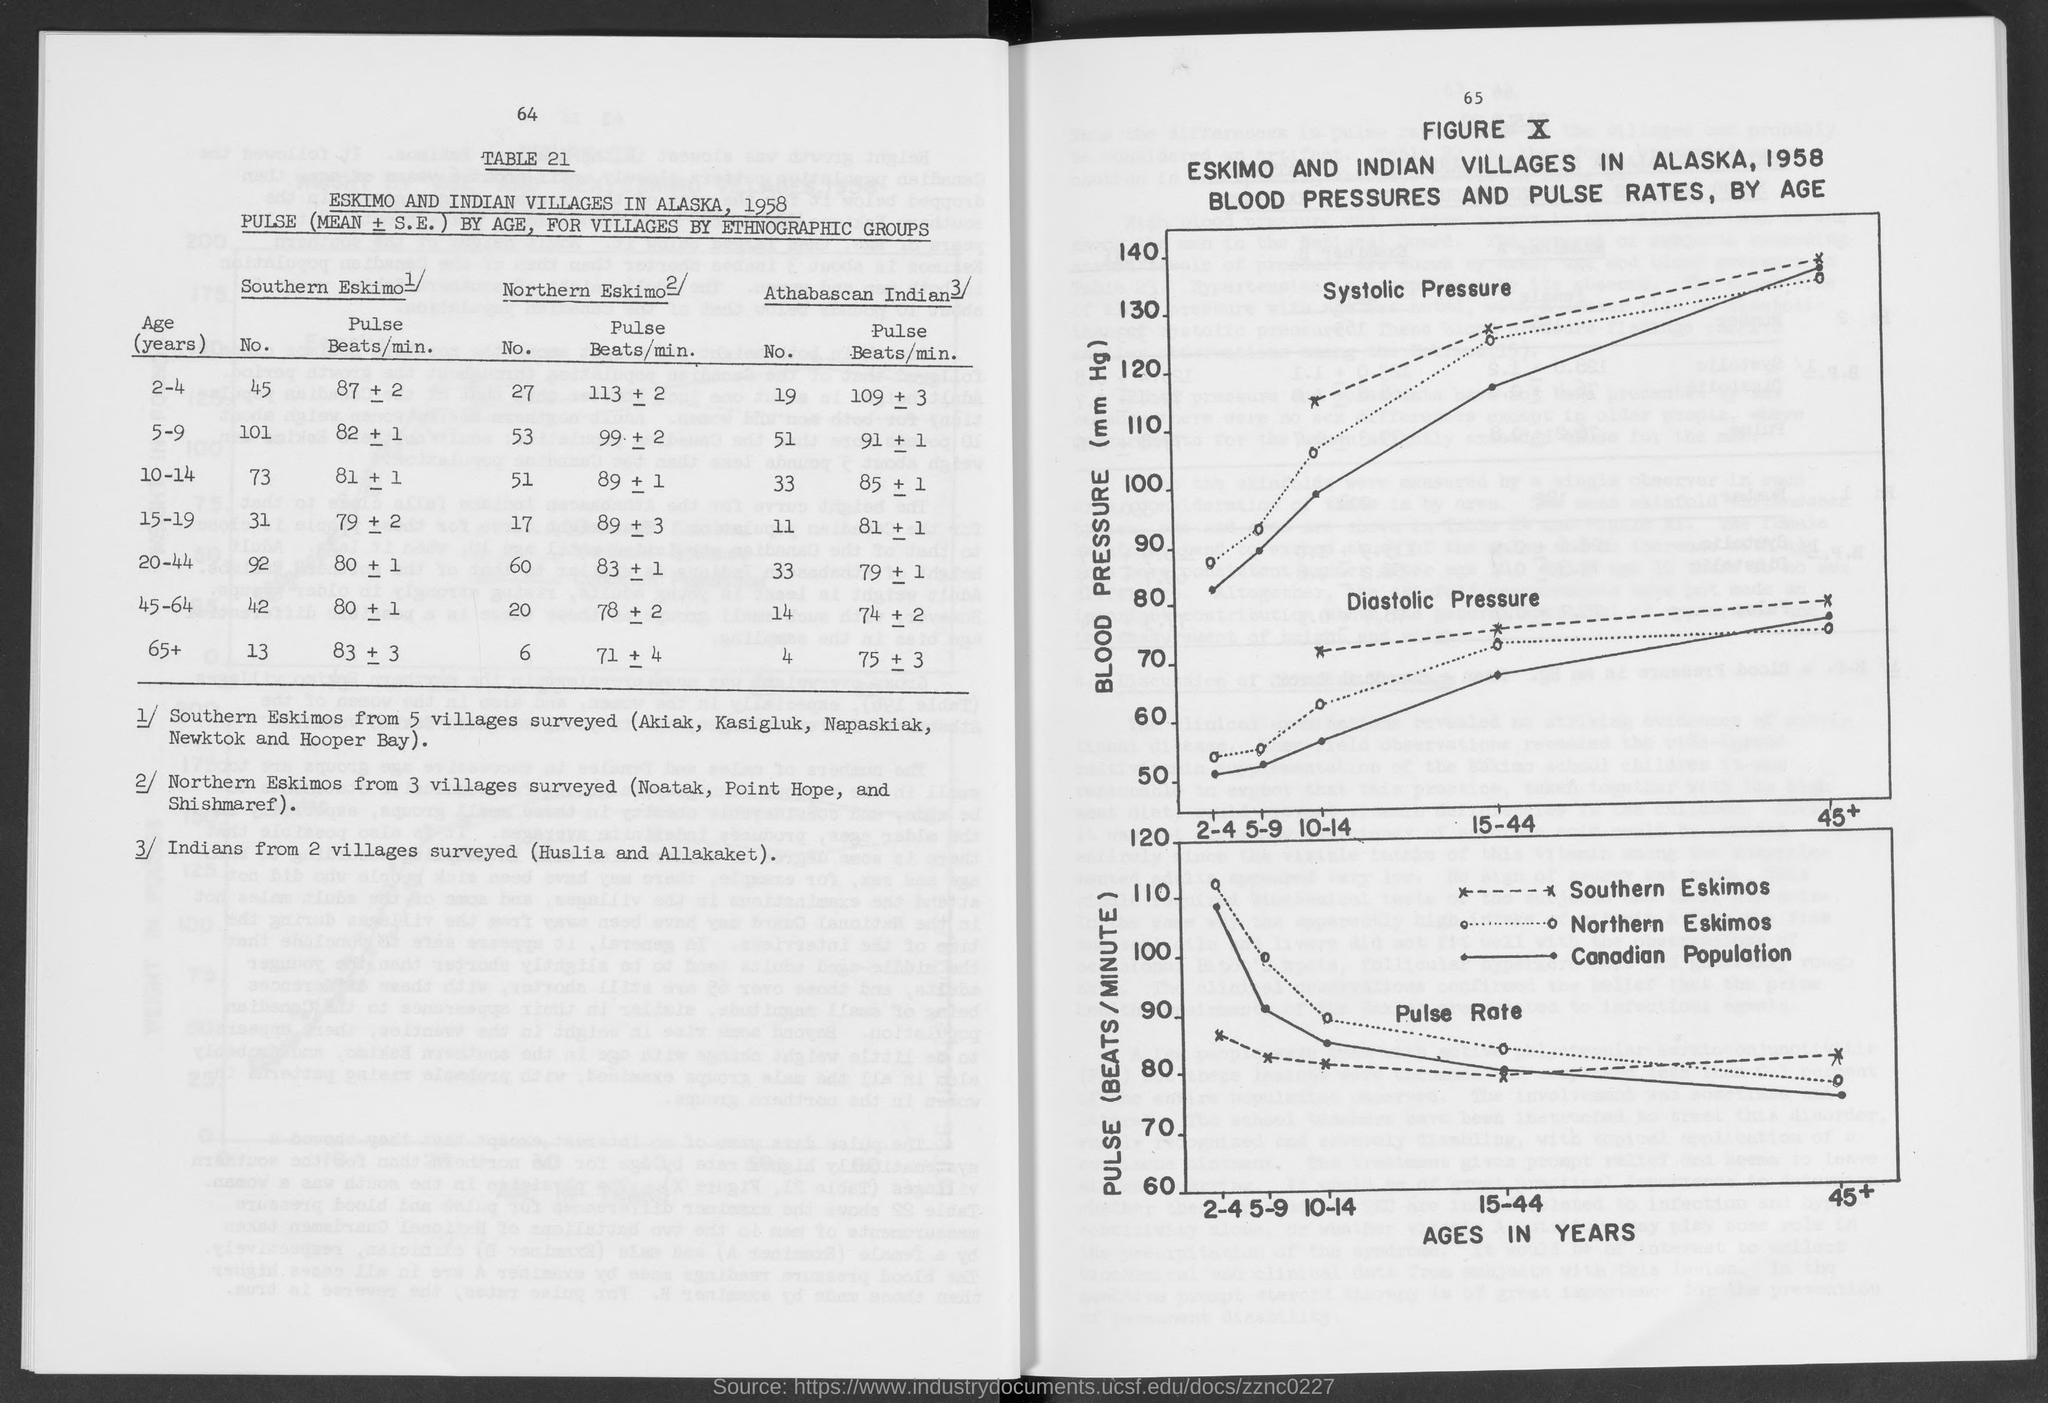What is represented by a bold line?
Make the answer very short. Canadian population. 